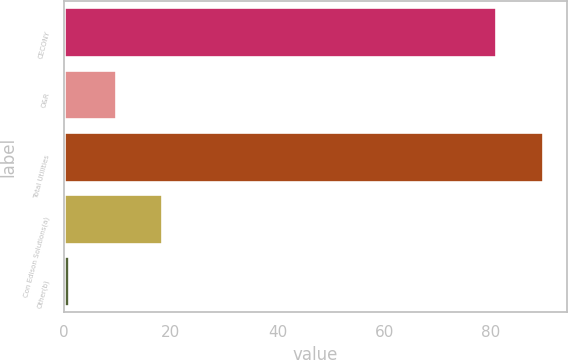<chart> <loc_0><loc_0><loc_500><loc_500><bar_chart><fcel>CECONY<fcel>O&R<fcel>Total Utilities<fcel>Con Edison Solutions(a)<fcel>Other(b)<nl><fcel>81<fcel>9.7<fcel>89.7<fcel>18.4<fcel>1<nl></chart> 